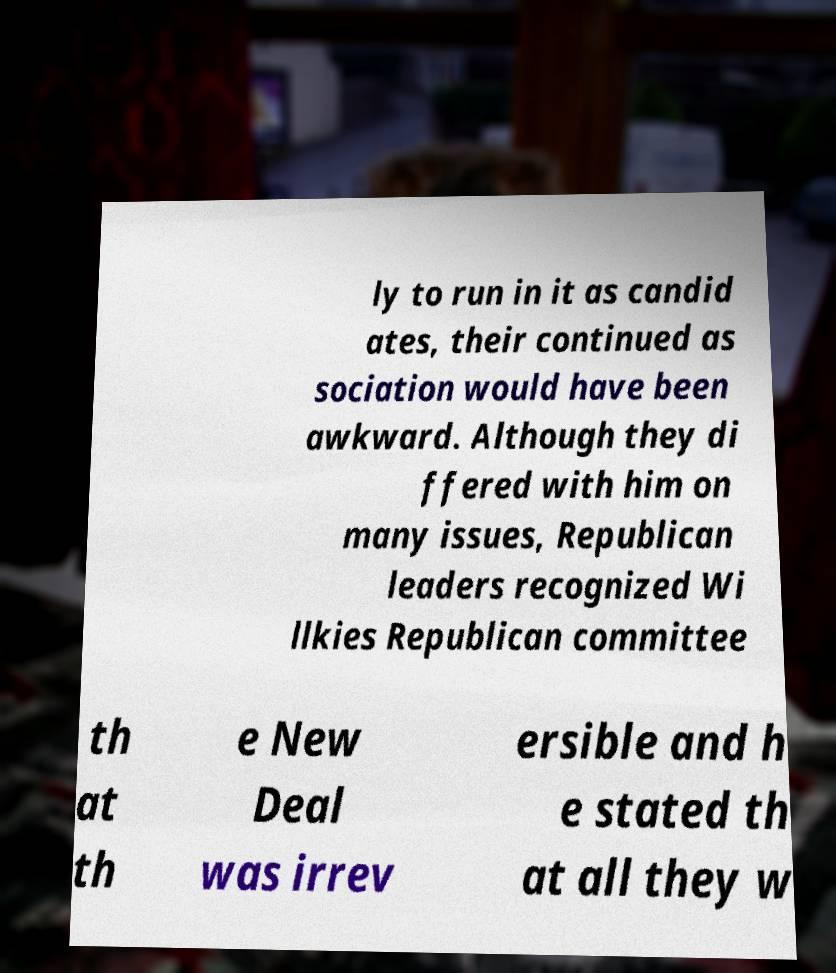Could you assist in decoding the text presented in this image and type it out clearly? ly to run in it as candid ates, their continued as sociation would have been awkward. Although they di ffered with him on many issues, Republican leaders recognized Wi llkies Republican committee th at th e New Deal was irrev ersible and h e stated th at all they w 